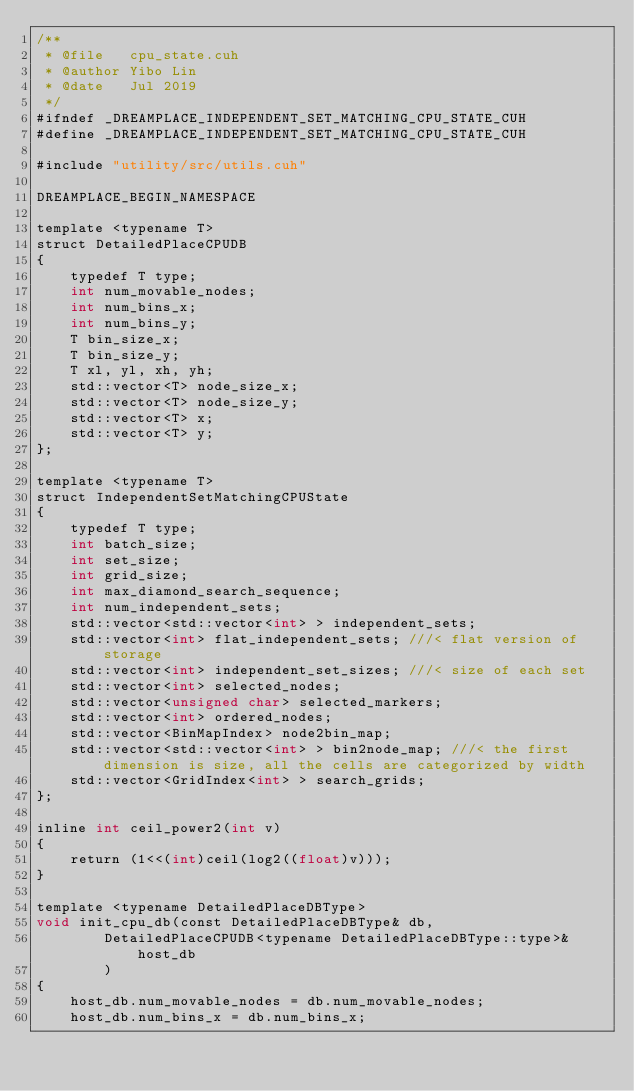<code> <loc_0><loc_0><loc_500><loc_500><_Cuda_>/**
 * @file   cpu_state.cuh
 * @author Yibo Lin
 * @date   Jul 2019
 */
#ifndef _DREAMPLACE_INDEPENDENT_SET_MATCHING_CPU_STATE_CUH
#define _DREAMPLACE_INDEPENDENT_SET_MATCHING_CPU_STATE_CUH

#include "utility/src/utils.cuh"

DREAMPLACE_BEGIN_NAMESPACE

template <typename T>
struct DetailedPlaceCPUDB
{
    typedef T type; 
    int num_movable_nodes; 
    int num_bins_x; 
    int num_bins_y; 
    T bin_size_x; 
    T bin_size_y;
    T xl, yl, xh, yh; 
    std::vector<T> node_size_x; 
    std::vector<T> node_size_y; 
    std::vector<T> x; 
    std::vector<T> y; 
};

template <typename T>
struct IndependentSetMatchingCPUState
{
    typedef T type; 
    int batch_size; 
    int set_size; 
    int grid_size; 
    int max_diamond_search_sequence; 
    int num_independent_sets; 
    std::vector<std::vector<int> > independent_sets; 
    std::vector<int> flat_independent_sets; ///< flat version of storage 
    std::vector<int> independent_set_sizes; ///< size of each set 
    std::vector<int> selected_nodes; 
    std::vector<unsigned char> selected_markers; 
    std::vector<int> ordered_nodes; 
    std::vector<BinMapIndex> node2bin_map;  
    std::vector<std::vector<int> > bin2node_map; ///< the first dimension is size, all the cells are categorized by width 
    std::vector<GridIndex<int> > search_grids; 
};

inline int ceil_power2(int v)
{
    return (1<<(int)ceil(log2((float)v)));
}

template <typename DetailedPlaceDBType>
void init_cpu_db(const DetailedPlaceDBType& db, 
        DetailedPlaceCPUDB<typename DetailedPlaceDBType::type>& host_db
        )
{
    host_db.num_movable_nodes = db.num_movable_nodes; 
    host_db.num_bins_x = db.num_bins_x; </code> 